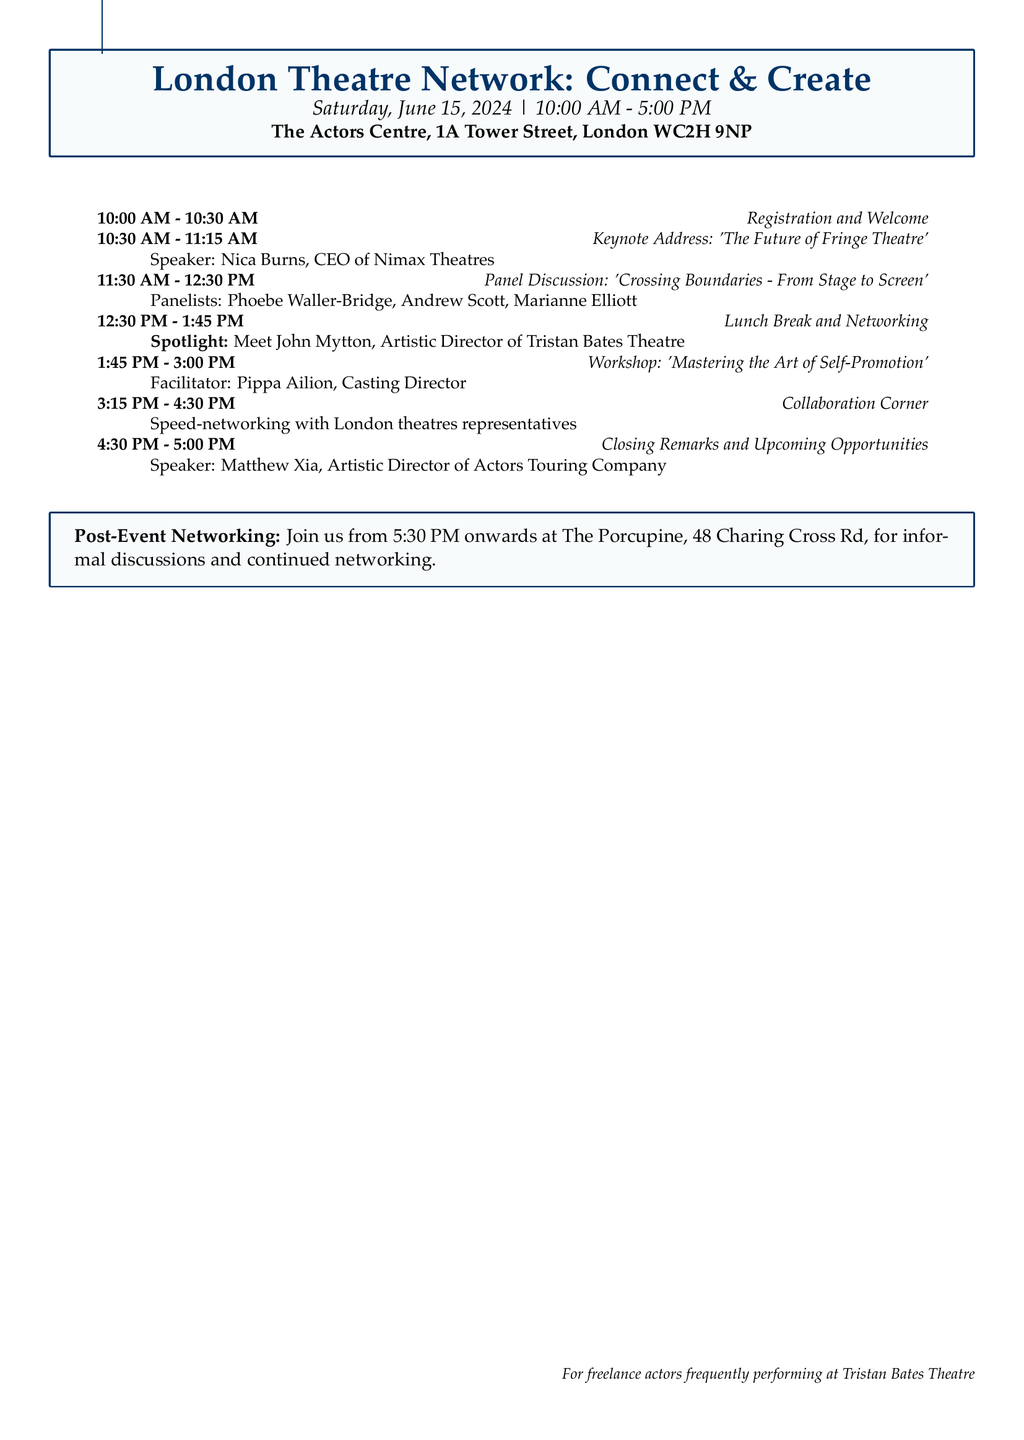What is the date of the event? The date of the event is clearly indicated in the header section of the agenda.
Answer: Saturday, June 15, 2024 Who is the keynote speaker? The keynote address title and the speaker's name are specified in the second section of the agenda.
Answer: Nica Burns What time does the registration begin? The start time for registration is mentioned in the first section of the agenda.
Answer: 10:00 AM What is the topic of the panel discussion? The topic of the panel discussion is outlined in its title in the agenda.
Answer: Crossing Boundaries - From Stage to Screen Which theatre director is a panelist? The names of the panelists are listed in the description of the panel discussion.
Answer: Marianne Elliott How long is the lunch break? The duration of the lunch break is noted in that portion of the agenda.
Answer: 1 hour 15 minutes What is the focus during the lunch break? The special focus is highlighted in the lunch break section of the agenda.
Answer: Spotlight on Tristan Bates Theatre Where will post-event networking take place? The location for post-event networking is specified at the end of the agenda.
Answer: The Porcupine, 48 Charing Cross Rd Who will give the closing remarks? The speaker for the closing remarks is indicated in the final section of the agenda.
Answer: Matthew Xia 